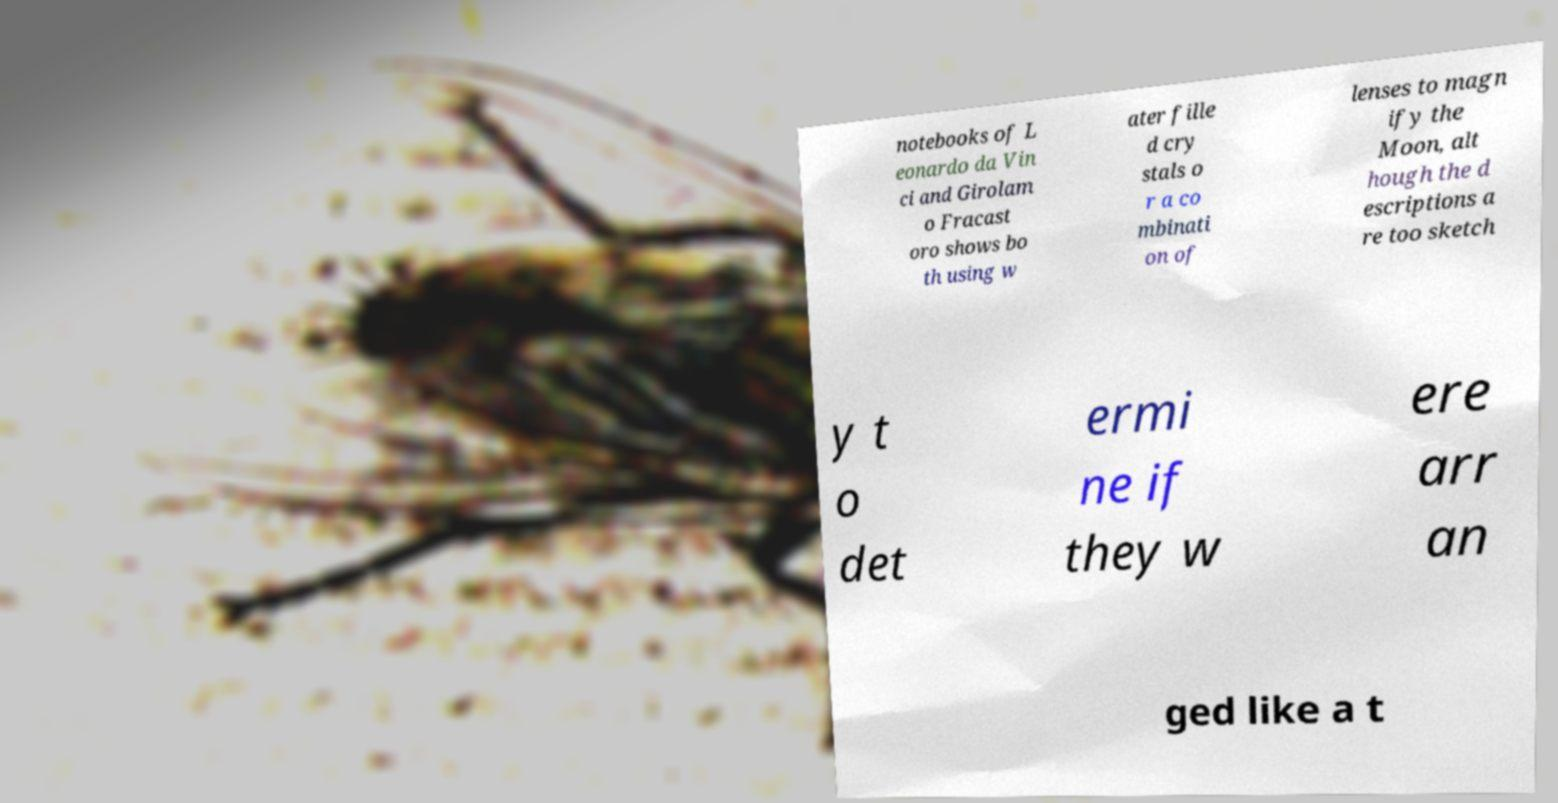Please identify and transcribe the text found in this image. notebooks of L eonardo da Vin ci and Girolam o Fracast oro shows bo th using w ater fille d cry stals o r a co mbinati on of lenses to magn ify the Moon, alt hough the d escriptions a re too sketch y t o det ermi ne if they w ere arr an ged like a t 